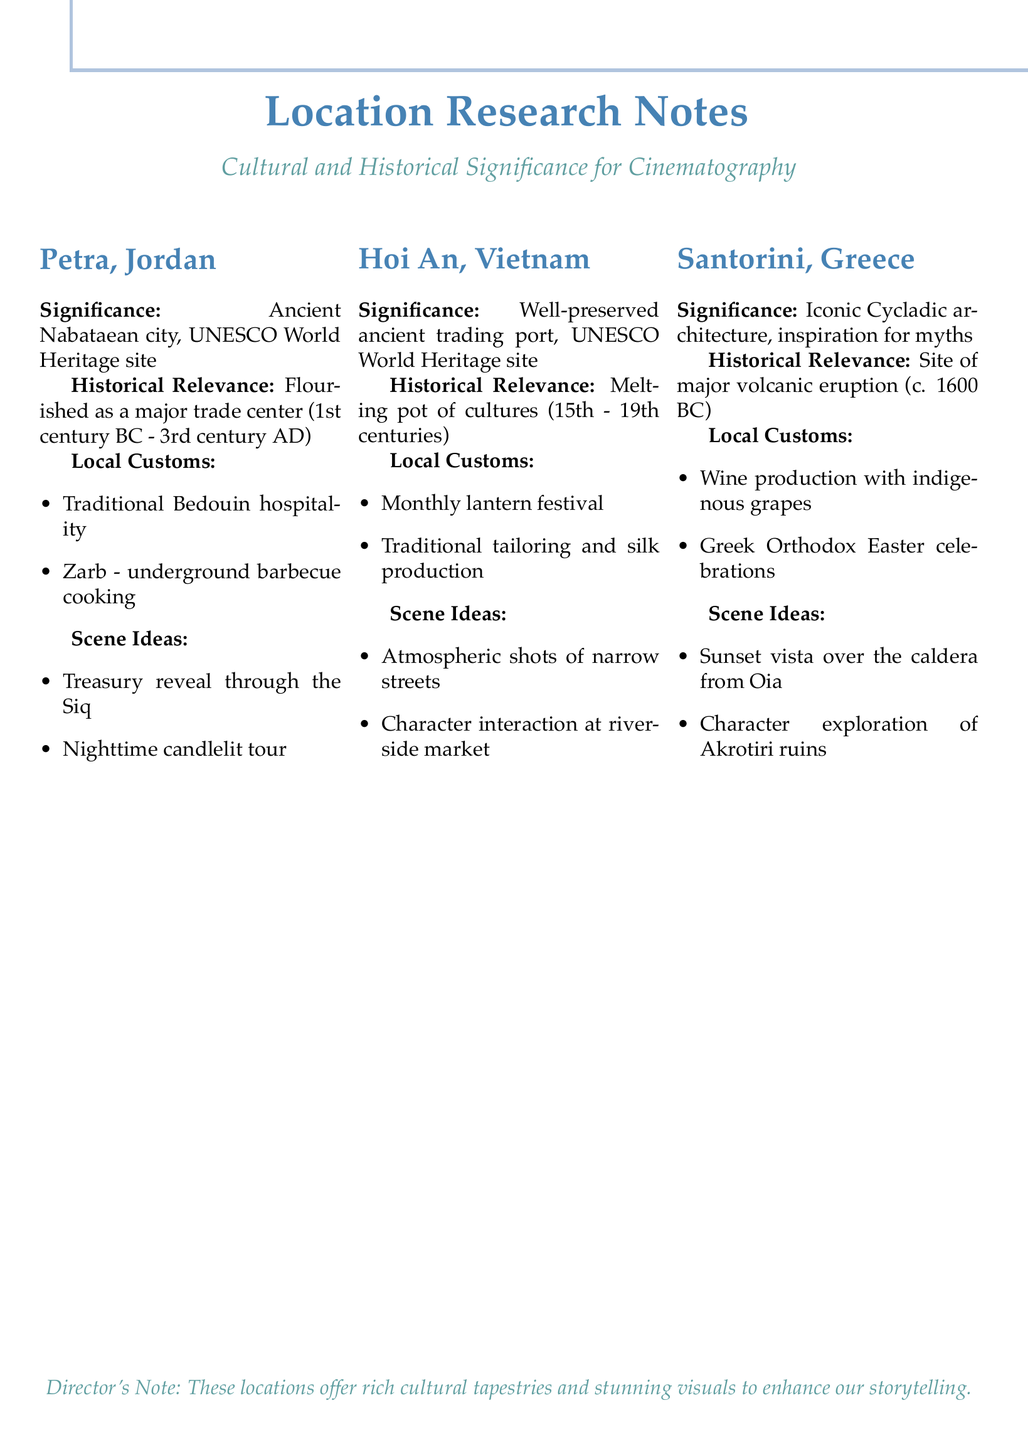What is the cultural significance of Petra? The cultural significance of Petra is that it is an ancient Nabataean city and a UNESCO World Heritage site.
Answer: Ancient Nabataean city, UNESCO World Heritage site What method is used for underground barbecue cooking in Petra? The method used for underground barbecue cooking in Petra is called Zarb.
Answer: Zarb What notable scene idea is suggested for Santorini? A notable scene idea suggested for Santorini is capturing the sunset vista over the caldera from Oia.
Answer: Sunset vista over the caldera from Oia Which cultures influenced Hoi An historically? Hoi An was influenced historically by Chinese, Japanese, and European cultures.
Answer: Chinese, Japanese, and European What local custom involves a festival in Hoi An? The local custom that involves a festival in Hoi An is the monthly lantern festival.
Answer: Monthly lantern festival What is the historical relevance of Santorini? The historical relevance of Santorini is that it was the site of one of the largest volcanic eruptions in recorded history.
Answer: Site of one of the largest volcanic eruptions in recorded history What unique local product is associated with Santorini? The unique local product associated with Santorini is wine produced using indigenous grape varieties.
Answer: Wine production using indigenous grape varieties What is the main theme of the director's note? The main theme of the director's note is that the locations offer rich cultural tapestries and stunning visuals to enhance storytelling.
Answer: Rich cultural tapestries and stunning visuals What scene idea involves a bustling market in Hoi An? The scene idea that involves a bustling market in Hoi An is character interaction at a riverside market.
Answer: Character interaction at a bustling riverside market 